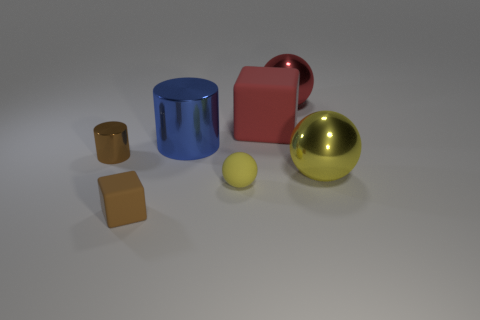There is a small object that is both in front of the yellow metallic object and left of the large metallic cylinder; what is its shape?
Keep it short and to the point. Cube. Are there any yellow shiny spheres that have the same size as the red metallic ball?
Keep it short and to the point. Yes. Do the tiny matte block and the big metal object behind the big blue cylinder have the same color?
Provide a succinct answer. No. What is the big yellow ball made of?
Keep it short and to the point. Metal. What is the color of the cube in front of the red block?
Provide a succinct answer. Brown. How many objects have the same color as the tiny matte sphere?
Provide a succinct answer. 1. What number of things are behind the large shiny cylinder and to the right of the large matte cube?
Make the answer very short. 1. What shape is the rubber object that is the same size as the blue shiny thing?
Your response must be concise. Cube. The yellow rubber ball is what size?
Offer a very short reply. Small. What is the material of the big thing that is to the right of the metallic ball that is behind the big thing left of the tiny ball?
Provide a short and direct response. Metal. 